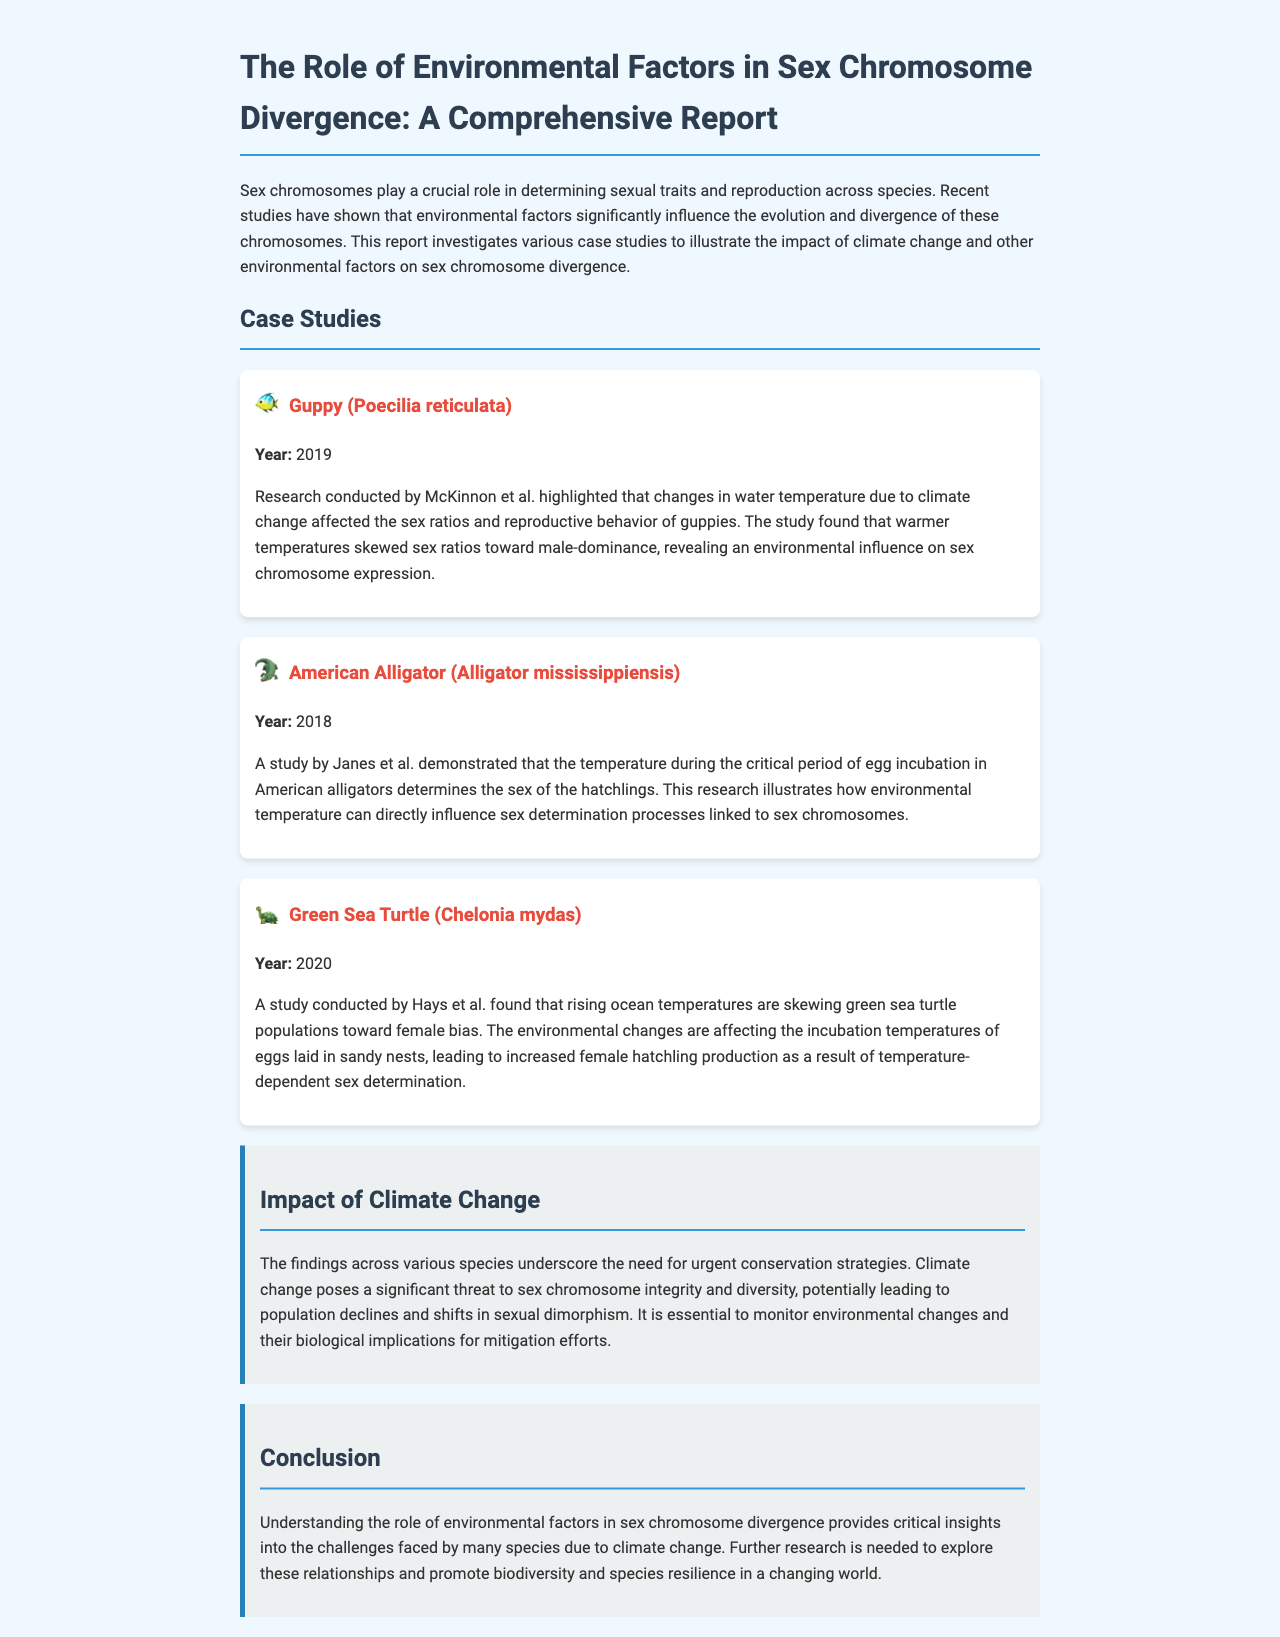what is the title of the report? The title is explicitly stated in the header section of the document.
Answer: The Role of Environmental Factors in Sex Chromosome Divergence: A Comprehensive Report who conducted the study on guppies? The author of the guppy study is highlighted in the case study section with their publication year.
Answer: McKinnon et al what year was the study on American alligators published? The publication year is mentioned in the respective case study of the American alligator.
Answer: 2018 which species is mentioned as being affected by rising ocean temperatures? This species is discussed in the case studies section regarding temperature effects on their population.
Answer: Green Sea Turtle how does temperature affect American alligator hatchlings? The document explains the direct relationship between temperature during egg incubation and the sex of the hatchlings.
Answer: Determines sex what is the primary environmental factor discussed in relation to sex chromosome divergence? This factor is identified as a significant influence throughout the report and case studies.
Answer: Climate change what do the findings suggest about population impacts due to climate change? This information is provided in the impact section of the report.
Answer: Population declines what type of studies does the report investigate? The document highlights specific research methods used in examining the subjects discussed.
Answer: Case studies 